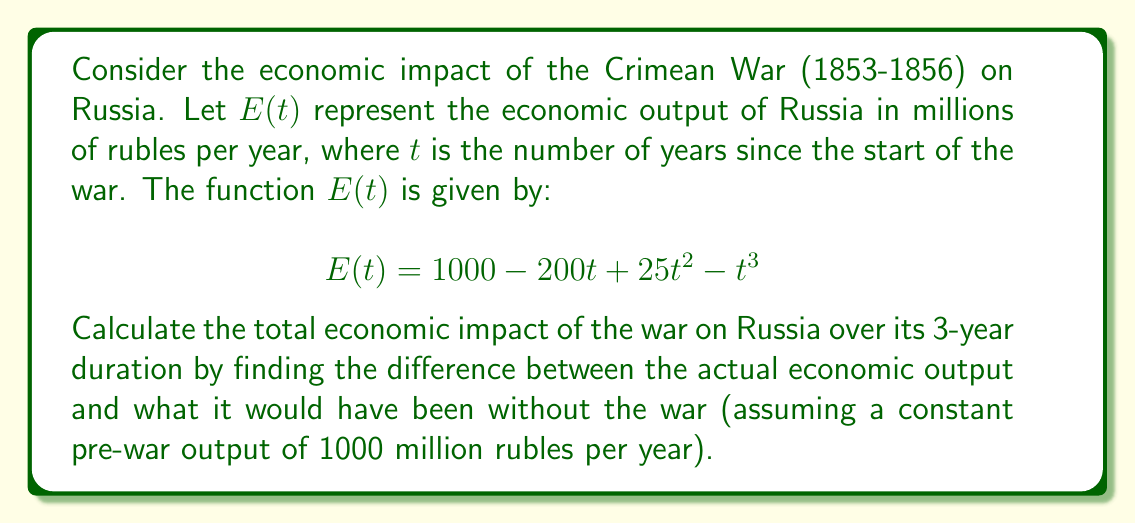Can you answer this question? To solve this problem, we need to follow these steps:

1) First, we need to find the total actual economic output during the war. This can be done by integrating $E(t)$ from 0 to 3:

   $$\int_0^3 E(t) dt = \int_0^3 (1000 - 200t + 25t^2 - t^3) dt$$

2) Integrate each term:
   
   $$\left[1000t - 100t^2 + \frac{25}{3}t^3 - \frac{1}{4}t^4\right]_0^3$$

3) Evaluate at the limits:
   
   $$\left(3000 - 900 + 75 - \frac{81}{4}\right) - (0) = 2154.75$$

4) Now, we need to calculate what the output would have been without the war. This would be the constant 1000 million rubles per year for 3 years:

   $$3 * 1000 = 3000$$

5) The economic impact is the difference between what would have been without the war and the actual output:

   $$3000 - 2154.75 = 845.25$$

Therefore, the total economic impact of the Crimean War on Russia over its 3-year duration was a loss of 845.25 million rubles.
Answer: 845.25 million rubles 